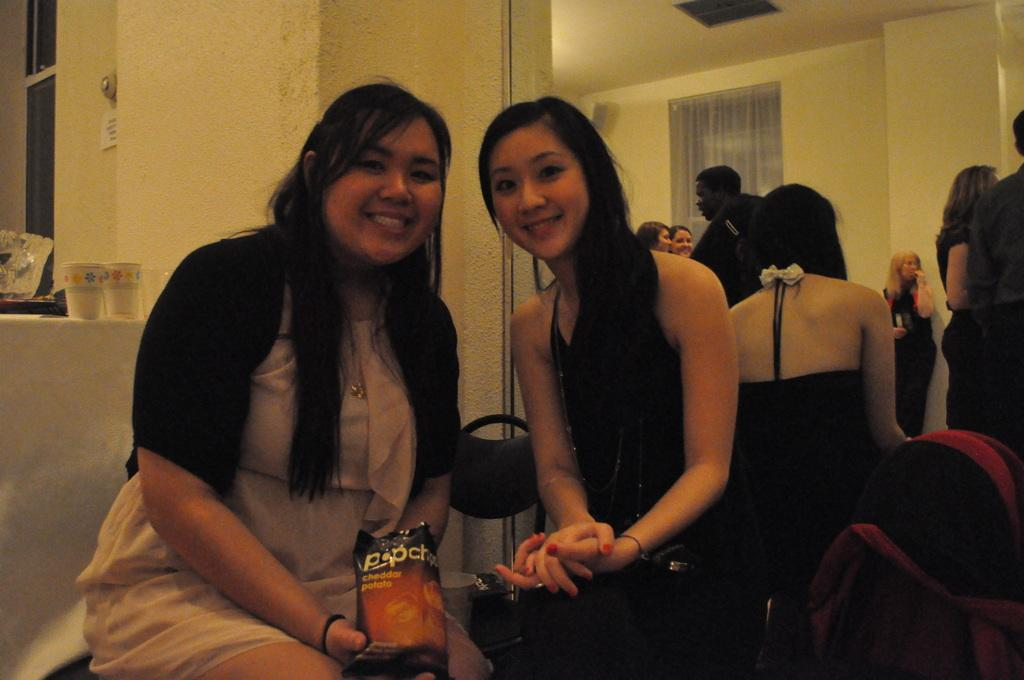How many people are in the image? There are two women in the image. What are the women doing in the image? The women are sitting and smiling. What can be seen in the background of the image? There is a mirror in the backdrop of the image. What is visible in the mirror? People are visible in the mirror. What type of division can be seen in the image? There is no division present in the image; it features two women sitting and smiling, with a mirror in the background. What kind of wall is visible in the image? There is no wall visible in the image; it features two women sitting and smiling, with a mirror in the background. 